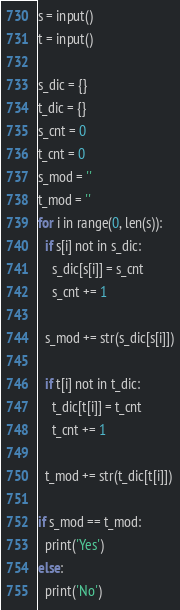<code> <loc_0><loc_0><loc_500><loc_500><_Python_>s = input()
t = input()

s_dic = {}
t_dic = {}
s_cnt = 0
t_cnt = 0
s_mod = ''
t_mod = ''
for i in range(0, len(s)):
  if s[i] not in s_dic:
    s_dic[s[i]] = s_cnt
    s_cnt += 1

  s_mod += str(s_dic[s[i]])
  
  if t[i] not in t_dic:
    t_dic[t[i]] = t_cnt
    t_cnt += 1
  
  t_mod += str(t_dic[t[i]])
  
if s_mod == t_mod:
  print('Yes')
else:
  print('No')</code> 